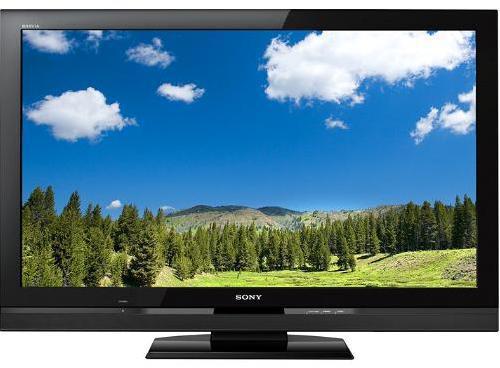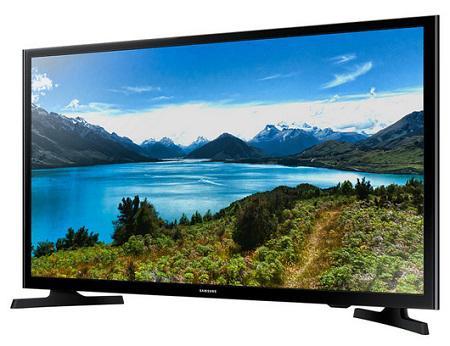The first image is the image on the left, the second image is the image on the right. For the images displayed, is the sentence "One of the screens is showing a tropical scene." factually correct? Answer yes or no. No. 